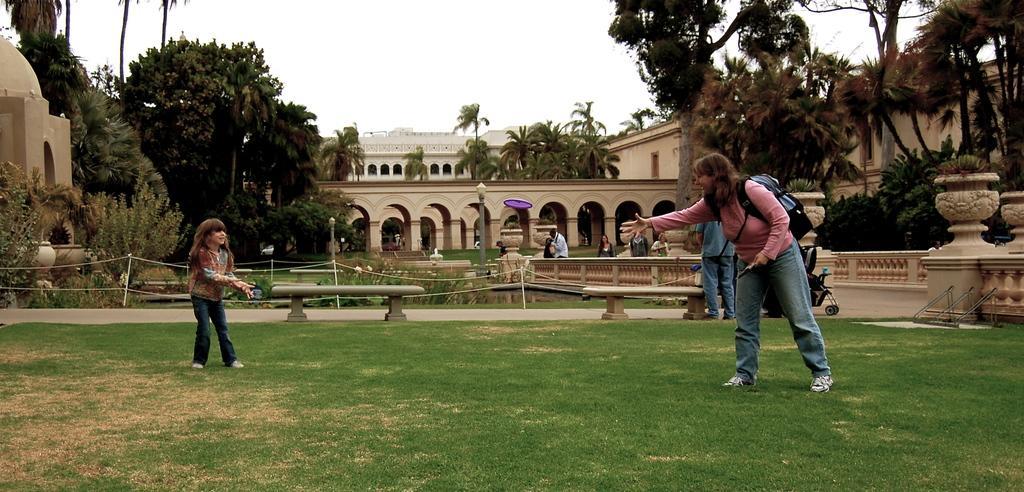In one or two sentences, can you explain what this image depicts? In this picture there are two people playing a game and we can see Frisbee in the air and grass. There are people and we can see railings, plants, lights, poles, pots, benches, trees and buildings. In the background of the image we can see the sky. 